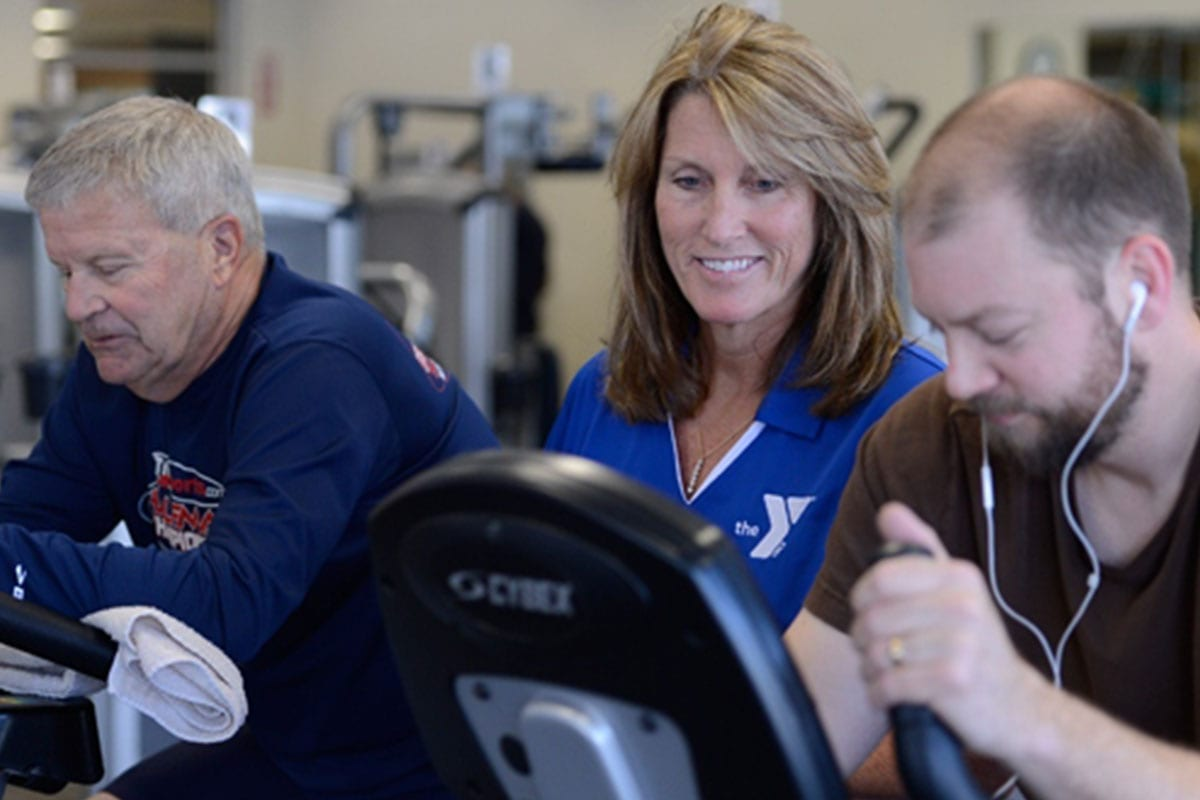What kind of exercises do you think these individuals are performing, and how might these exercises benefit their health? The individuals appear to be using stationary bikes, which are excellent for cardiovascular exercises. These exercises can improve heart health, increase lung capacity, and enhance overall endurance. Additionally, cycling is a low-impact activity that can help in weight management, reduce stress, and strengthen the muscles in the lower body, including the quadriceps, hamstrings, and calves. How might the presence of others working out in the sharegpt4v/same space impact individual performance and motivation? Working out in the presence of others can significantly boost an individual's motivation and performance. This phenomenon, known as the 'social facilitation effect,' suggests that people tend to perform better when they are being observed by others or when they are part of a group. The shared experience of exercising can create a supportive and competitive atmosphere, encouraging individuals to push themselves harder. Additionally, seeing others working out diligently can serve as a source of inspiration and motivation, fostering a sense of community and camaraderie. 